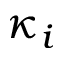Convert formula to latex. <formula><loc_0><loc_0><loc_500><loc_500>\kappa _ { i }</formula> 